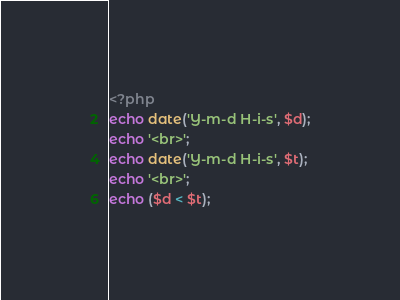<code> <loc_0><loc_0><loc_500><loc_500><_PHP_><?php
echo date('Y-m-d H-i-s', $d);
echo '<br>';
echo date('Y-m-d H-i-s', $t);
echo '<br>';
echo ($d < $t);</code> 